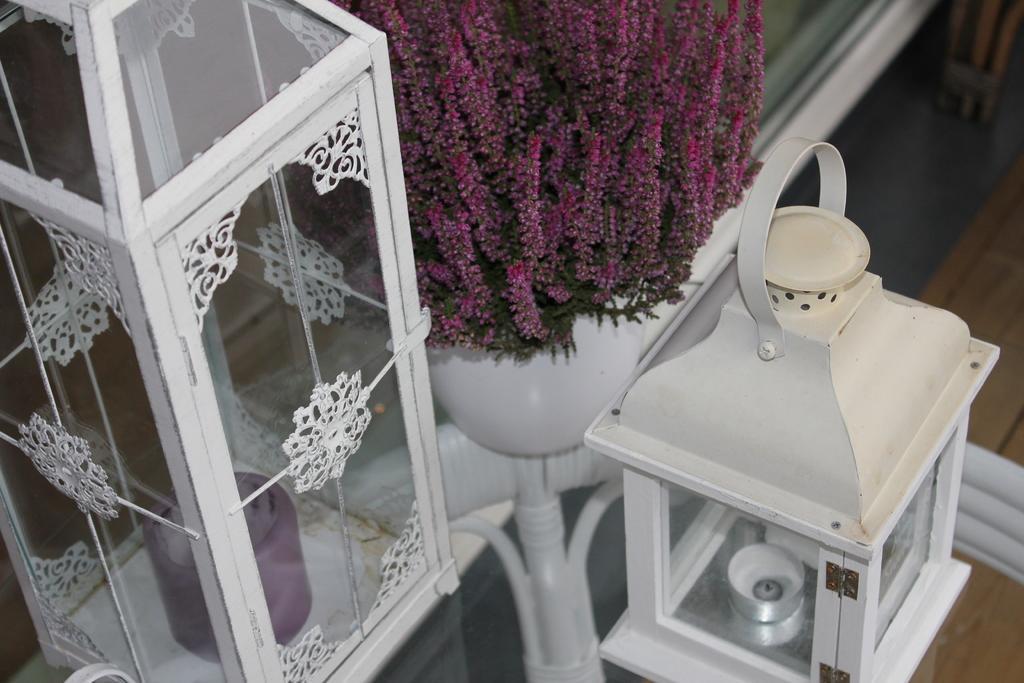Describe this image in one or two sentences. In this image there is a glass table. On the table there are candles in the glass box. 